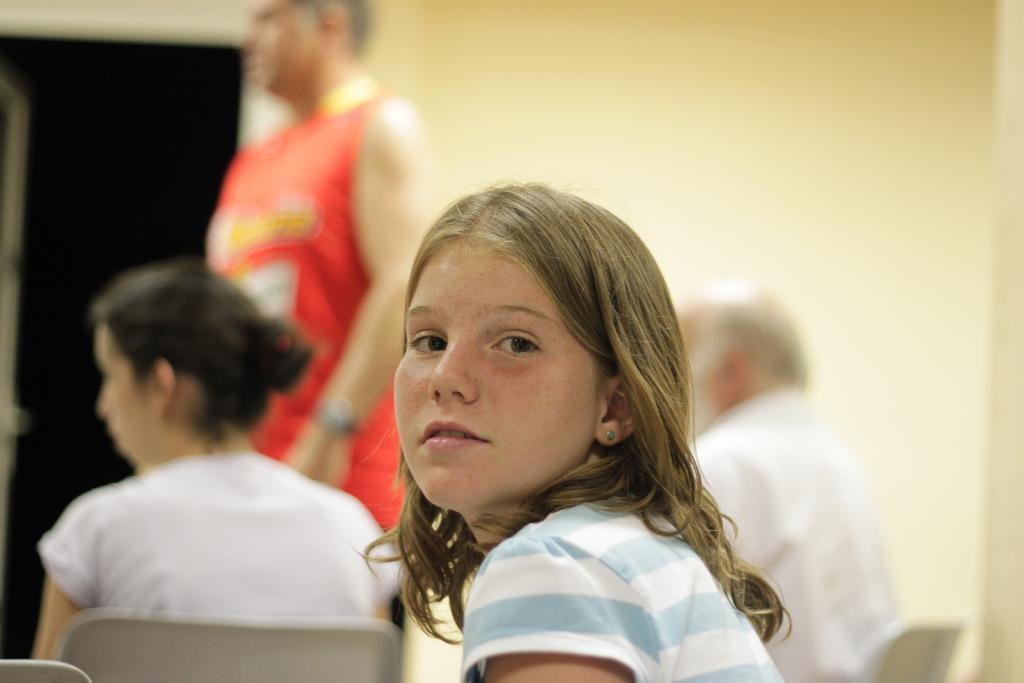How many people are sitting on chairs in the image? There are three people sitting on chairs in the image. What is the man in the image doing? There is a man standing on the floor in the image. What can be seen behind the people in the image? There is a wall visible behind the people in the image. What type of bomb is being thrown by the beast in the image? There is no bomb or beast present in the image. 